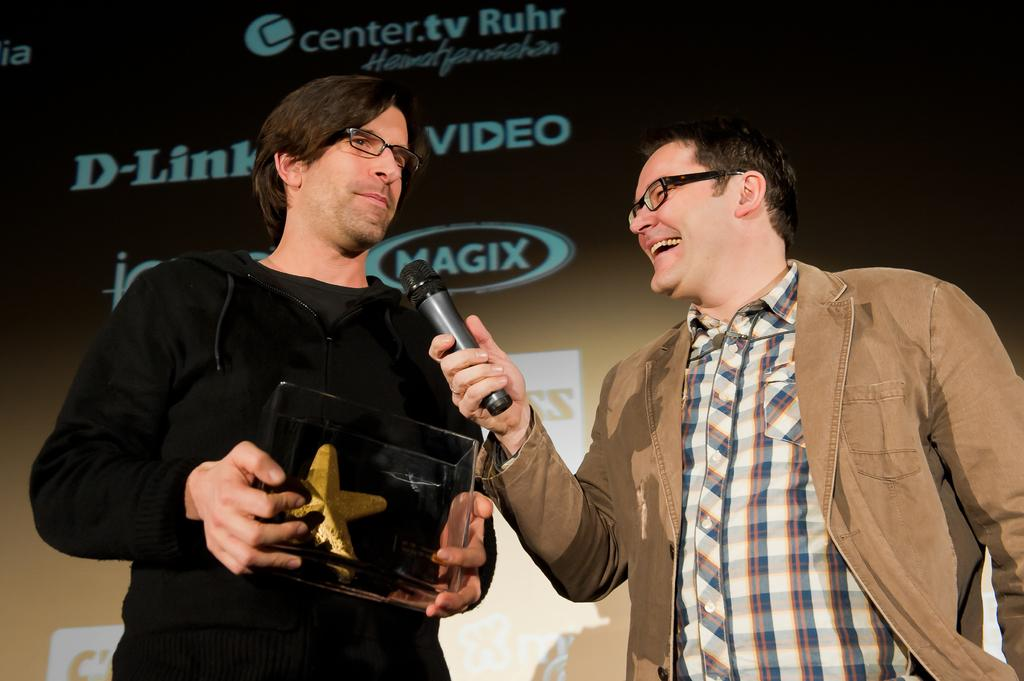How many people are in the image? There are two people in the image. What is the man on the right side holding? The man on the right side is holding a mic. What can be seen in the background of the image? There is a banner in the background of the image. How many frogs are jumping on the plough in the image? There are no frogs or ploughs present in the image. 